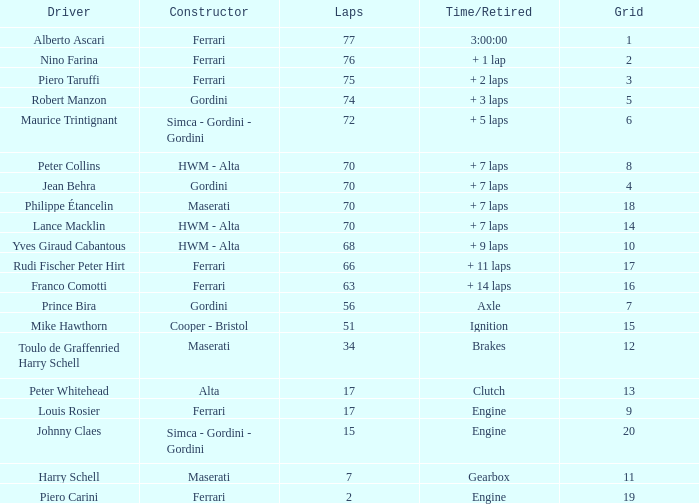What is the highest grid for ferrari's with 2 laps? 19.0. 